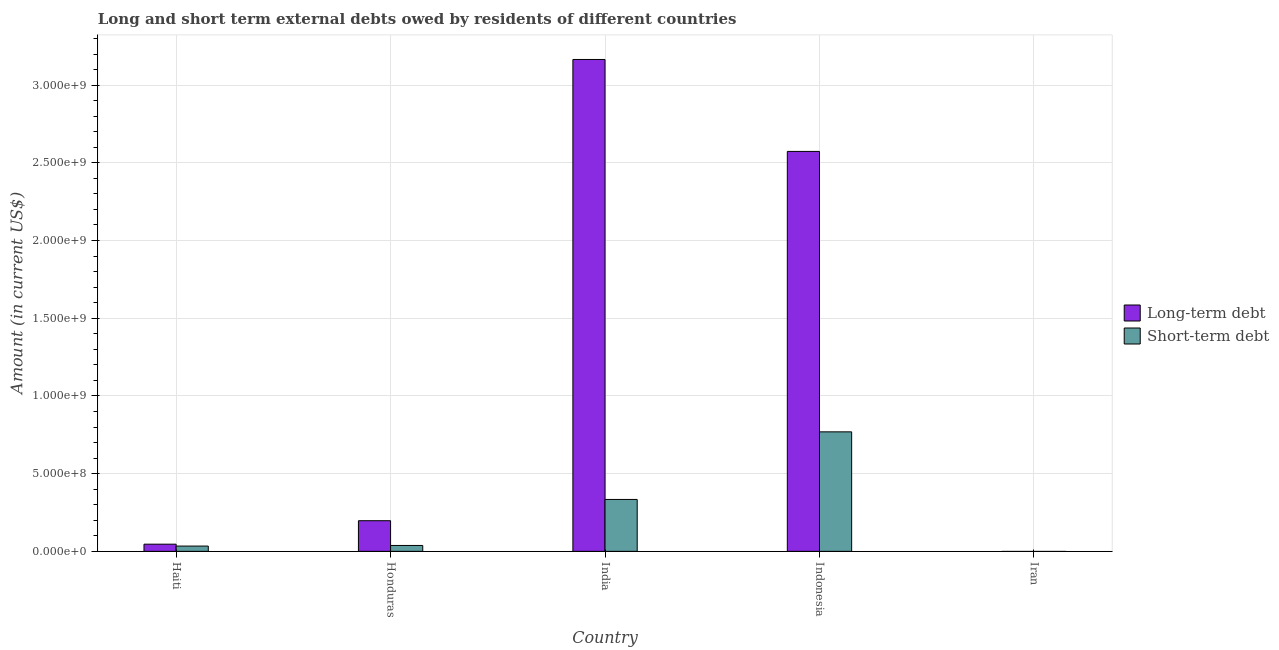How many bars are there on the 1st tick from the left?
Your answer should be very brief. 2. How many bars are there on the 2nd tick from the right?
Give a very brief answer. 2. What is the label of the 5th group of bars from the left?
Give a very brief answer. Iran. What is the long-term debts owed by residents in Indonesia?
Ensure brevity in your answer.  2.57e+09. Across all countries, what is the maximum long-term debts owed by residents?
Ensure brevity in your answer.  3.17e+09. Across all countries, what is the minimum long-term debts owed by residents?
Provide a succinct answer. 0. In which country was the short-term debts owed by residents maximum?
Your answer should be compact. Indonesia. What is the total long-term debts owed by residents in the graph?
Make the answer very short. 5.98e+09. What is the difference between the long-term debts owed by residents in Honduras and that in Indonesia?
Give a very brief answer. -2.38e+09. What is the difference between the long-term debts owed by residents in Haiti and the short-term debts owed by residents in Indonesia?
Provide a succinct answer. -7.23e+08. What is the average long-term debts owed by residents per country?
Your answer should be very brief. 1.20e+09. What is the difference between the long-term debts owed by residents and short-term debts owed by residents in Honduras?
Give a very brief answer. 1.59e+08. In how many countries, is the short-term debts owed by residents greater than 2000000000 US$?
Your answer should be very brief. 0. What is the ratio of the long-term debts owed by residents in India to that in Indonesia?
Give a very brief answer. 1.23. Is the short-term debts owed by residents in Honduras less than that in Indonesia?
Provide a succinct answer. Yes. What is the difference between the highest and the second highest short-term debts owed by residents?
Your answer should be very brief. 4.35e+08. What is the difference between the highest and the lowest short-term debts owed by residents?
Provide a short and direct response. 7.69e+08. Is the sum of the long-term debts owed by residents in Honduras and Indonesia greater than the maximum short-term debts owed by residents across all countries?
Your answer should be compact. Yes. Are all the bars in the graph horizontal?
Offer a very short reply. No. Are the values on the major ticks of Y-axis written in scientific E-notation?
Keep it short and to the point. Yes. Does the graph contain any zero values?
Provide a succinct answer. Yes. What is the title of the graph?
Provide a succinct answer. Long and short term external debts owed by residents of different countries. What is the label or title of the X-axis?
Your answer should be compact. Country. What is the Amount (in current US$) of Long-term debt in Haiti?
Provide a short and direct response. 4.62e+07. What is the Amount (in current US$) of Short-term debt in Haiti?
Provide a succinct answer. 3.40e+07. What is the Amount (in current US$) of Long-term debt in Honduras?
Offer a terse response. 1.97e+08. What is the Amount (in current US$) of Short-term debt in Honduras?
Your response must be concise. 3.80e+07. What is the Amount (in current US$) in Long-term debt in India?
Keep it short and to the point. 3.17e+09. What is the Amount (in current US$) of Short-term debt in India?
Your response must be concise. 3.34e+08. What is the Amount (in current US$) of Long-term debt in Indonesia?
Give a very brief answer. 2.57e+09. What is the Amount (in current US$) of Short-term debt in Indonesia?
Give a very brief answer. 7.69e+08. What is the Amount (in current US$) of Long-term debt in Iran?
Provide a short and direct response. 0. Across all countries, what is the maximum Amount (in current US$) of Long-term debt?
Offer a terse response. 3.17e+09. Across all countries, what is the maximum Amount (in current US$) of Short-term debt?
Keep it short and to the point. 7.69e+08. Across all countries, what is the minimum Amount (in current US$) in Short-term debt?
Keep it short and to the point. 0. What is the total Amount (in current US$) of Long-term debt in the graph?
Your response must be concise. 5.98e+09. What is the total Amount (in current US$) of Short-term debt in the graph?
Provide a short and direct response. 1.18e+09. What is the difference between the Amount (in current US$) of Long-term debt in Haiti and that in Honduras?
Offer a very short reply. -1.51e+08. What is the difference between the Amount (in current US$) in Short-term debt in Haiti and that in Honduras?
Ensure brevity in your answer.  -4.00e+06. What is the difference between the Amount (in current US$) in Long-term debt in Haiti and that in India?
Make the answer very short. -3.12e+09. What is the difference between the Amount (in current US$) in Short-term debt in Haiti and that in India?
Provide a succinct answer. -3.00e+08. What is the difference between the Amount (in current US$) of Long-term debt in Haiti and that in Indonesia?
Ensure brevity in your answer.  -2.53e+09. What is the difference between the Amount (in current US$) of Short-term debt in Haiti and that in Indonesia?
Provide a succinct answer. -7.35e+08. What is the difference between the Amount (in current US$) in Long-term debt in Honduras and that in India?
Your response must be concise. -2.97e+09. What is the difference between the Amount (in current US$) of Short-term debt in Honduras and that in India?
Your answer should be very brief. -2.96e+08. What is the difference between the Amount (in current US$) of Long-term debt in Honduras and that in Indonesia?
Make the answer very short. -2.38e+09. What is the difference between the Amount (in current US$) of Short-term debt in Honduras and that in Indonesia?
Your response must be concise. -7.31e+08. What is the difference between the Amount (in current US$) in Long-term debt in India and that in Indonesia?
Provide a succinct answer. 5.92e+08. What is the difference between the Amount (in current US$) of Short-term debt in India and that in Indonesia?
Provide a short and direct response. -4.35e+08. What is the difference between the Amount (in current US$) of Long-term debt in Haiti and the Amount (in current US$) of Short-term debt in Honduras?
Your response must be concise. 8.20e+06. What is the difference between the Amount (in current US$) of Long-term debt in Haiti and the Amount (in current US$) of Short-term debt in India?
Your answer should be very brief. -2.88e+08. What is the difference between the Amount (in current US$) of Long-term debt in Haiti and the Amount (in current US$) of Short-term debt in Indonesia?
Your response must be concise. -7.23e+08. What is the difference between the Amount (in current US$) of Long-term debt in Honduras and the Amount (in current US$) of Short-term debt in India?
Your response must be concise. -1.37e+08. What is the difference between the Amount (in current US$) of Long-term debt in Honduras and the Amount (in current US$) of Short-term debt in Indonesia?
Offer a terse response. -5.72e+08. What is the difference between the Amount (in current US$) of Long-term debt in India and the Amount (in current US$) of Short-term debt in Indonesia?
Your answer should be very brief. 2.40e+09. What is the average Amount (in current US$) of Long-term debt per country?
Your answer should be compact. 1.20e+09. What is the average Amount (in current US$) of Short-term debt per country?
Keep it short and to the point. 2.35e+08. What is the difference between the Amount (in current US$) in Long-term debt and Amount (in current US$) in Short-term debt in Haiti?
Offer a terse response. 1.22e+07. What is the difference between the Amount (in current US$) in Long-term debt and Amount (in current US$) in Short-term debt in Honduras?
Make the answer very short. 1.59e+08. What is the difference between the Amount (in current US$) in Long-term debt and Amount (in current US$) in Short-term debt in India?
Keep it short and to the point. 2.83e+09. What is the difference between the Amount (in current US$) in Long-term debt and Amount (in current US$) in Short-term debt in Indonesia?
Keep it short and to the point. 1.80e+09. What is the ratio of the Amount (in current US$) of Long-term debt in Haiti to that in Honduras?
Ensure brevity in your answer.  0.23. What is the ratio of the Amount (in current US$) in Short-term debt in Haiti to that in Honduras?
Ensure brevity in your answer.  0.89. What is the ratio of the Amount (in current US$) of Long-term debt in Haiti to that in India?
Provide a short and direct response. 0.01. What is the ratio of the Amount (in current US$) of Short-term debt in Haiti to that in India?
Make the answer very short. 0.1. What is the ratio of the Amount (in current US$) of Long-term debt in Haiti to that in Indonesia?
Your answer should be very brief. 0.02. What is the ratio of the Amount (in current US$) of Short-term debt in Haiti to that in Indonesia?
Your response must be concise. 0.04. What is the ratio of the Amount (in current US$) of Long-term debt in Honduras to that in India?
Give a very brief answer. 0.06. What is the ratio of the Amount (in current US$) in Short-term debt in Honduras to that in India?
Keep it short and to the point. 0.11. What is the ratio of the Amount (in current US$) in Long-term debt in Honduras to that in Indonesia?
Give a very brief answer. 0.08. What is the ratio of the Amount (in current US$) of Short-term debt in Honduras to that in Indonesia?
Offer a very short reply. 0.05. What is the ratio of the Amount (in current US$) of Long-term debt in India to that in Indonesia?
Offer a very short reply. 1.23. What is the ratio of the Amount (in current US$) in Short-term debt in India to that in Indonesia?
Make the answer very short. 0.43. What is the difference between the highest and the second highest Amount (in current US$) of Long-term debt?
Offer a very short reply. 5.92e+08. What is the difference between the highest and the second highest Amount (in current US$) in Short-term debt?
Provide a short and direct response. 4.35e+08. What is the difference between the highest and the lowest Amount (in current US$) of Long-term debt?
Make the answer very short. 3.17e+09. What is the difference between the highest and the lowest Amount (in current US$) in Short-term debt?
Make the answer very short. 7.69e+08. 